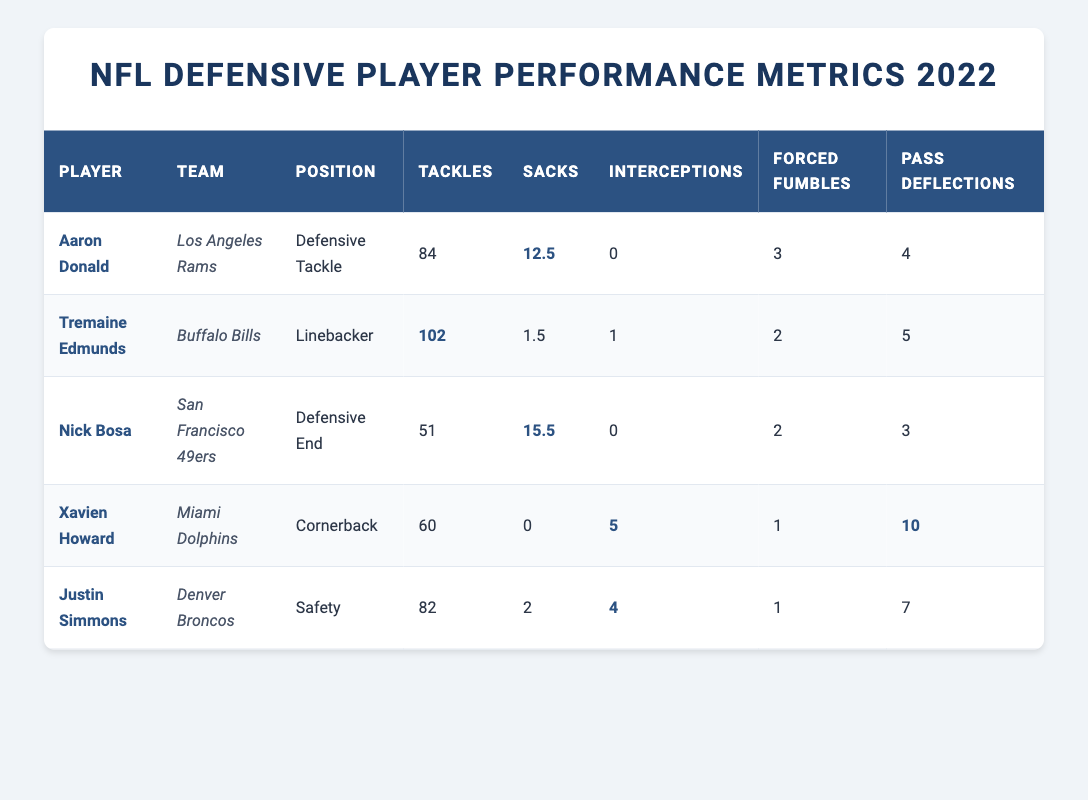What is the total number of tackles recorded by all players in the table? To find the total number of tackles, we add the tackles for each player. The players' tackles are: Aaron Donald (84), Tremaine Edmunds (102), Nick Bosa (51), Xavien Howard (60), and Justin Simmons (82). Summing these gives us 84 + 102 + 51 + 60 + 82 = 379.
Answer: 379 Who recorded the most sacks in the table? Referring to the column for sacks, Aaron Donald has 12.5 sacks, Nick Bosa has 15.5 sacks, Tremaine Edmunds has 1.5 sacks, Xavien Howard has 0 sacks, and Justin Simmons has 2 sacks. Comparing these values, Nick Bosa with 15.5 sacks has the highest total.
Answer: Nick Bosa Is it true that Xavien Howard had more interceptions than forced fumbles? From the table, Xavien Howard has 5 interceptions and 1 forced fumble. Since 5 is greater than 1, this statement is true.
Answer: Yes What is the average number of pass deflections among all players? To find the average pass deflections, we first sum the pass deflections for each player: Aaron Donald (4), Tremaine Edmunds (5), Nick Bosa (3), Xavien Howard (10), and Justin Simmons (7). Adding these numbers gives us 4 + 5 + 3 + 10 + 7 = 29. There are 5 players, so the average is 29/5 = 5.8.
Answer: 5.8 Which player recorded the highest number of interceptions and how many were there? Looking at the interceptions, Xavien Howard leads with 5 interceptions, while the others have fewer: Aaron Donald (0), Tremaine Edmunds (1), Nick Bosa (0), and Justin Simmons (4). So, Xavien Howard has the highest number.
Answer: Xavien Howard, 5 